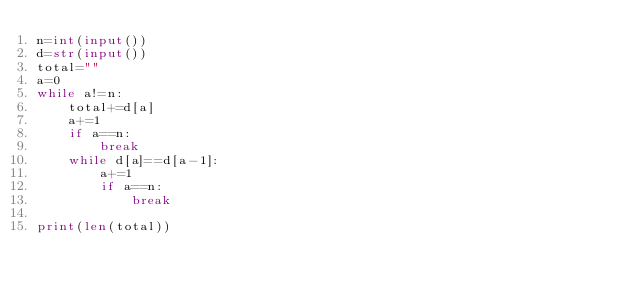<code> <loc_0><loc_0><loc_500><loc_500><_Python_>n=int(input())
d=str(input())
total=""
a=0
while a!=n:
    total+=d[a]
    a+=1
    if a==n:
        break
    while d[a]==d[a-1]:
        a+=1
        if a==n:
            break
    
print(len(total)) </code> 